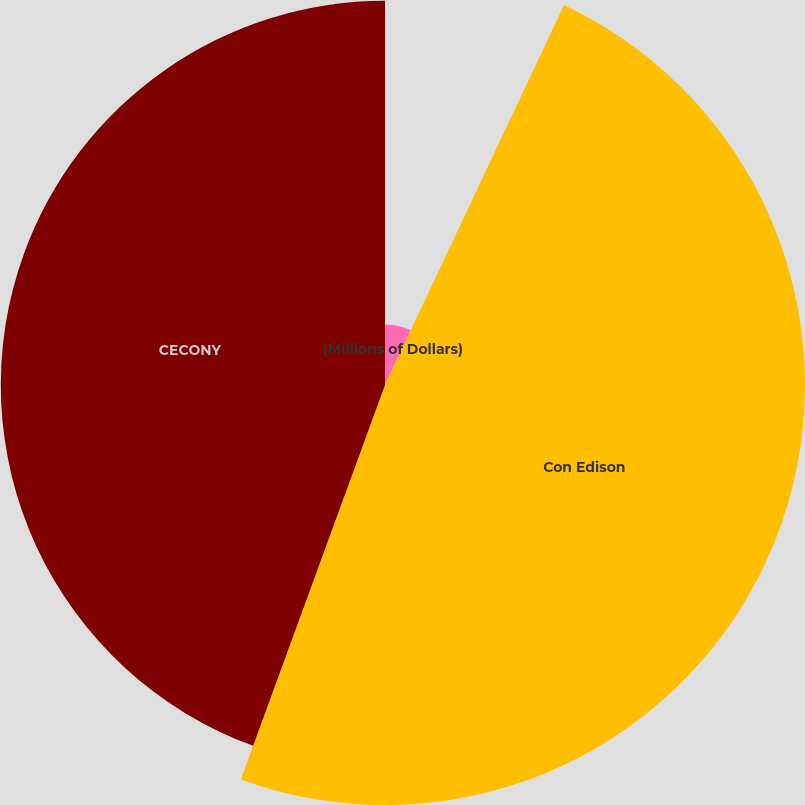Convert chart to OTSL. <chart><loc_0><loc_0><loc_500><loc_500><pie_chart><fcel>(Millions of Dollars)<fcel>Con Edison<fcel>CECONY<nl><fcel>7.01%<fcel>48.57%<fcel>44.43%<nl></chart> 